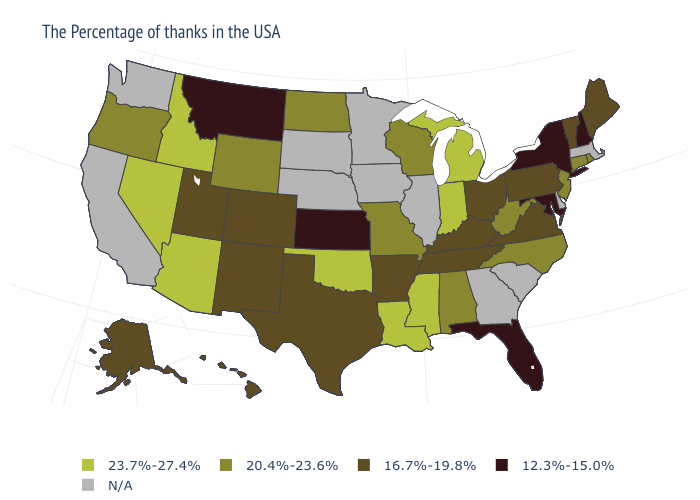Among the states that border Tennessee , which have the highest value?
Short answer required. Mississippi. How many symbols are there in the legend?
Keep it brief. 5. What is the highest value in states that border Florida?
Answer briefly. 20.4%-23.6%. Does Wisconsin have the lowest value in the MidWest?
Quick response, please. No. Name the states that have a value in the range 16.7%-19.8%?
Keep it brief. Maine, Vermont, Pennsylvania, Virginia, Ohio, Kentucky, Tennessee, Arkansas, Texas, Colorado, New Mexico, Utah, Alaska, Hawaii. Does Rhode Island have the highest value in the USA?
Short answer required. No. Name the states that have a value in the range 12.3%-15.0%?
Write a very short answer. New Hampshire, New York, Maryland, Florida, Kansas, Montana. Does the map have missing data?
Short answer required. Yes. Name the states that have a value in the range N/A?
Short answer required. Massachusetts, Delaware, South Carolina, Georgia, Illinois, Minnesota, Iowa, Nebraska, South Dakota, California, Washington. Which states hav the highest value in the Northeast?
Short answer required. Rhode Island, Connecticut, New Jersey. Does the first symbol in the legend represent the smallest category?
Answer briefly. No. Name the states that have a value in the range 16.7%-19.8%?
Be succinct. Maine, Vermont, Pennsylvania, Virginia, Ohio, Kentucky, Tennessee, Arkansas, Texas, Colorado, New Mexico, Utah, Alaska, Hawaii. What is the value of Nebraska?
Give a very brief answer. N/A. 